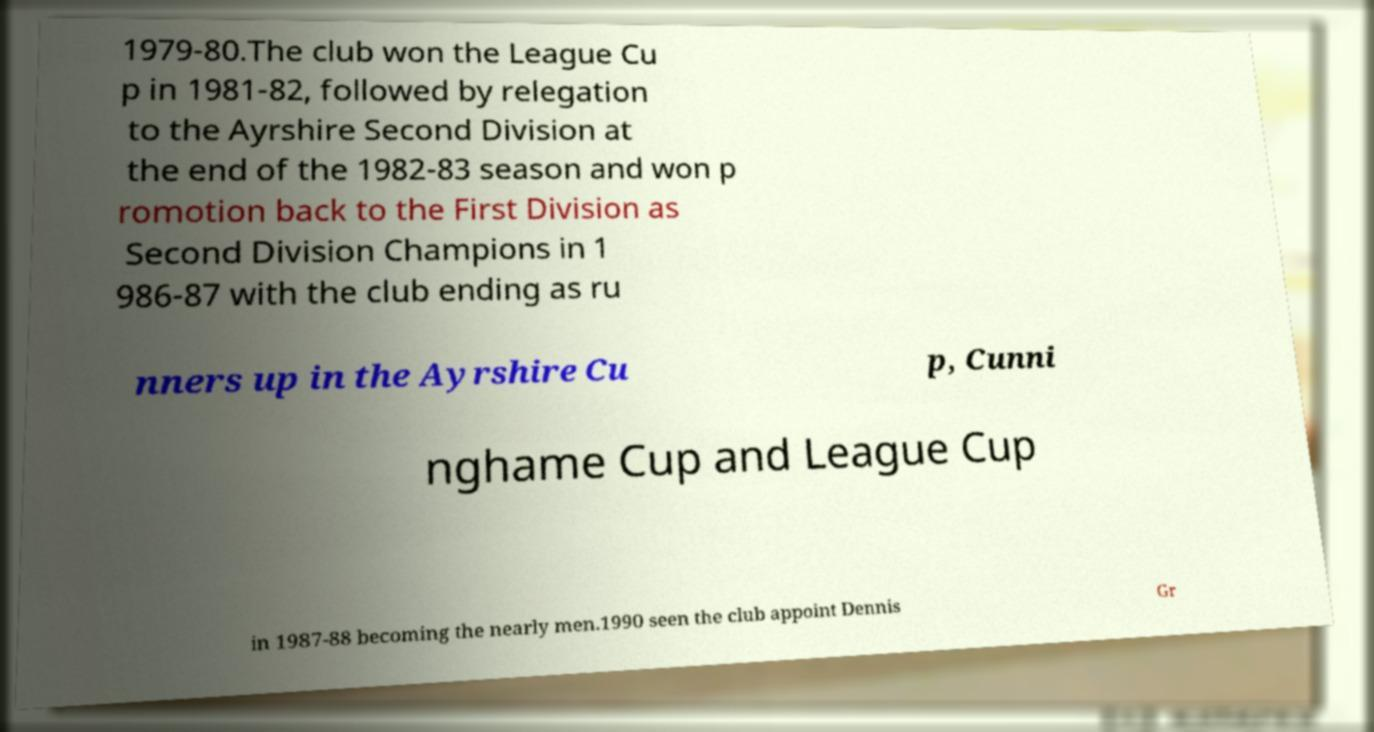Could you assist in decoding the text presented in this image and type it out clearly? 1979-80.The club won the League Cu p in 1981-82, followed by relegation to the Ayrshire Second Division at the end of the 1982-83 season and won p romotion back to the First Division as Second Division Champions in 1 986-87 with the club ending as ru nners up in the Ayrshire Cu p, Cunni nghame Cup and League Cup in 1987-88 becoming the nearly men.1990 seen the club appoint Dennis Gr 